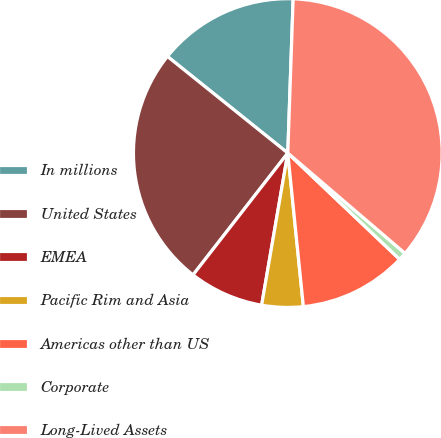<chart> <loc_0><loc_0><loc_500><loc_500><pie_chart><fcel>In millions<fcel>United States<fcel>EMEA<fcel>Pacific Rim and Asia<fcel>Americas other than US<fcel>Corporate<fcel>Long-Lived Assets<nl><fcel>14.79%<fcel>25.25%<fcel>7.81%<fcel>4.32%<fcel>11.3%<fcel>0.83%<fcel>35.72%<nl></chart> 